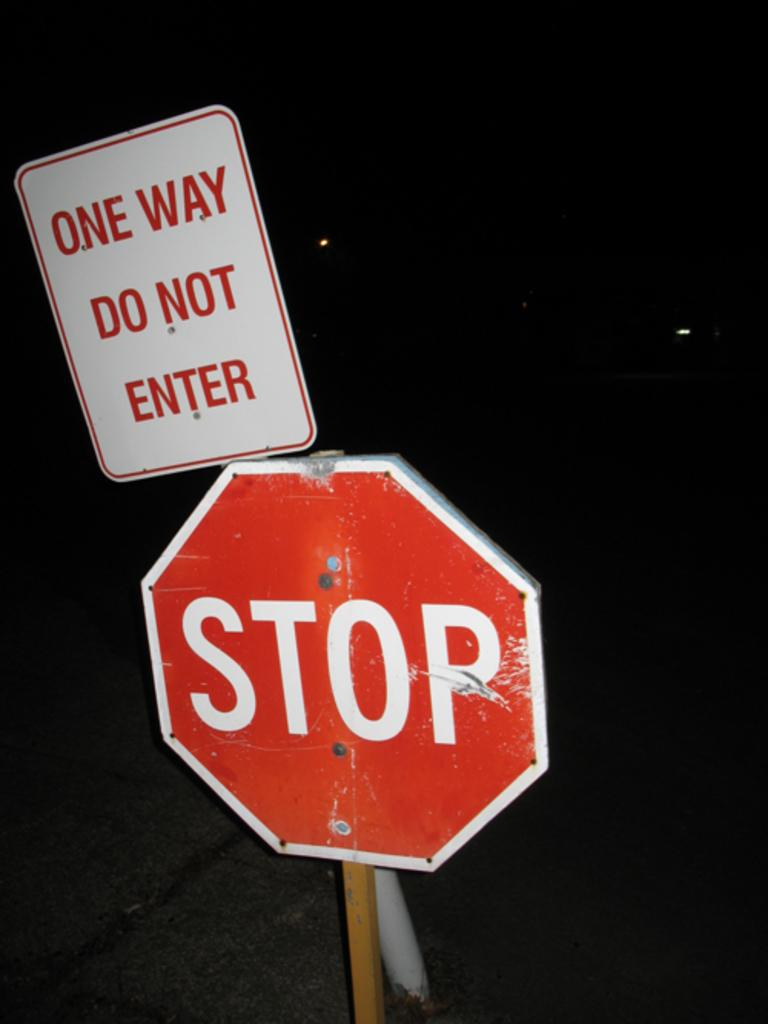<image>
Present a compact description of the photo's key features. The signs warn drivers to stop and not to enter. 